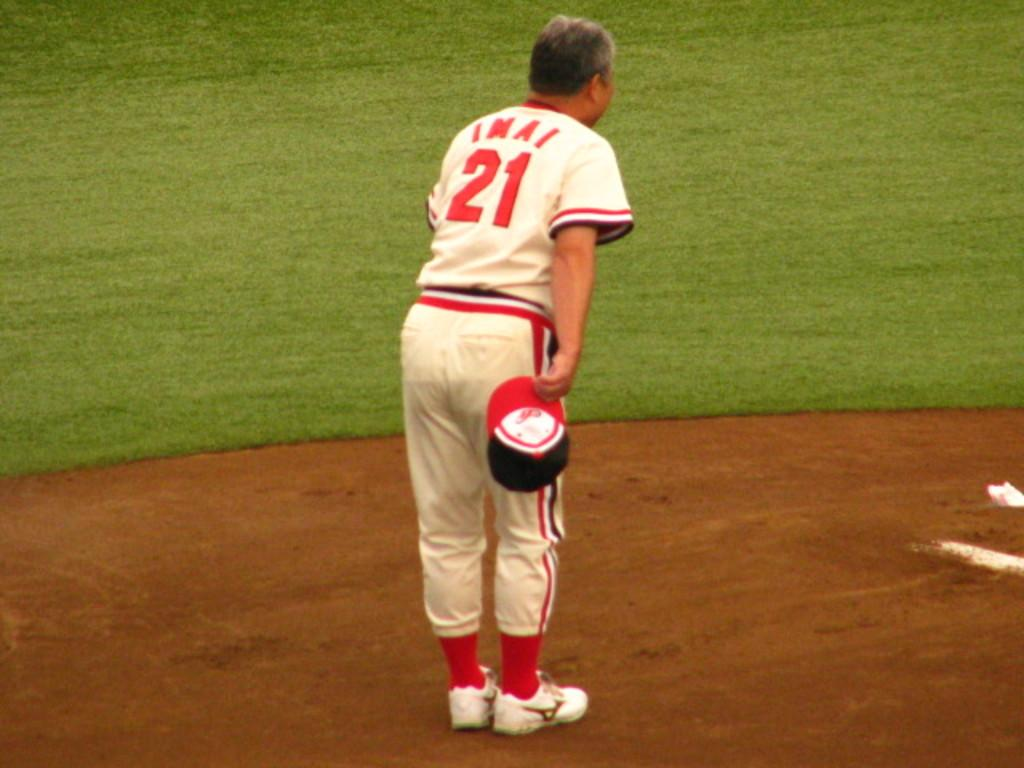<image>
Give a short and clear explanation of the subsequent image. a player with the number 21 on themselves 